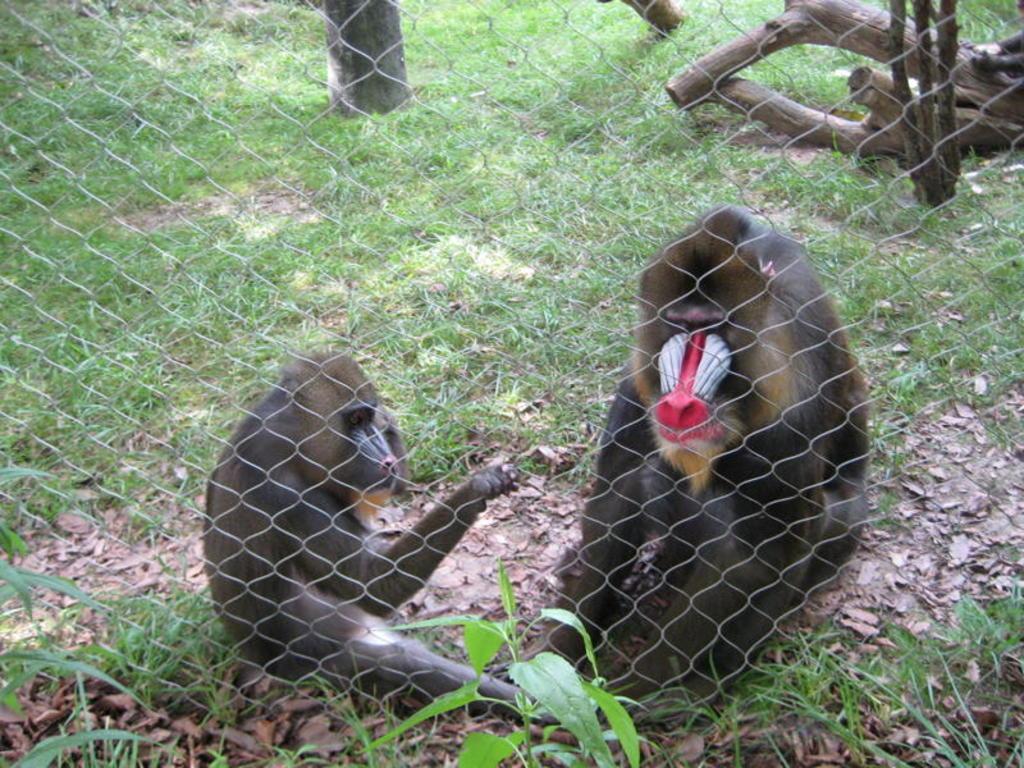Can you describe this image briefly? In this image we can see two monkeys sitting on the ground, one tree, some plants and grass on the ground. There is one fence, some wooden sticks on the ground. 